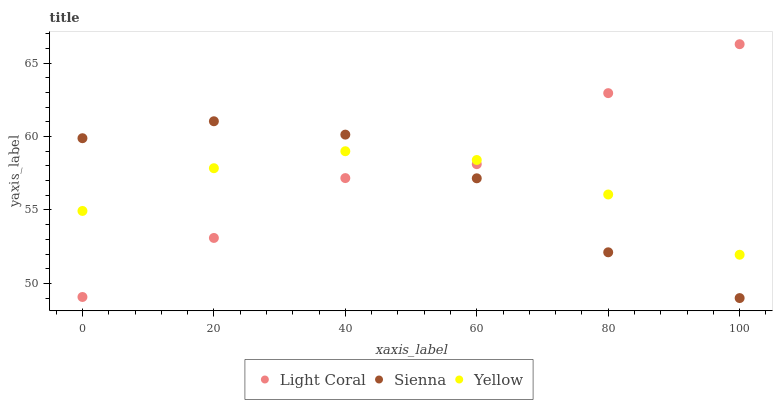Does Yellow have the minimum area under the curve?
Answer yes or no. Yes. Does Light Coral have the maximum area under the curve?
Answer yes or no. Yes. Does Sienna have the minimum area under the curve?
Answer yes or no. No. Does Sienna have the maximum area under the curve?
Answer yes or no. No. Is Yellow the smoothest?
Answer yes or no. Yes. Is Light Coral the roughest?
Answer yes or no. Yes. Is Sienna the smoothest?
Answer yes or no. No. Is Sienna the roughest?
Answer yes or no. No. Does Sienna have the lowest value?
Answer yes or no. Yes. Does Yellow have the lowest value?
Answer yes or no. No. Does Light Coral have the highest value?
Answer yes or no. Yes. Does Sienna have the highest value?
Answer yes or no. No. Does Sienna intersect Yellow?
Answer yes or no. Yes. Is Sienna less than Yellow?
Answer yes or no. No. Is Sienna greater than Yellow?
Answer yes or no. No. 